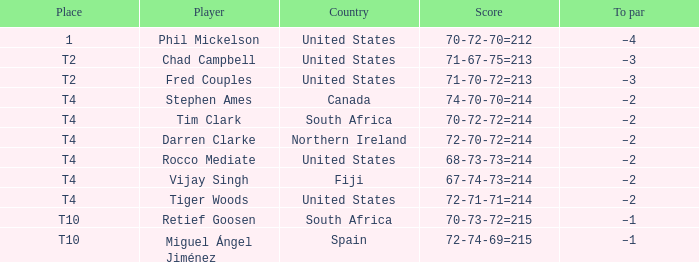What was the score for Spain? 72-74-69=215. 